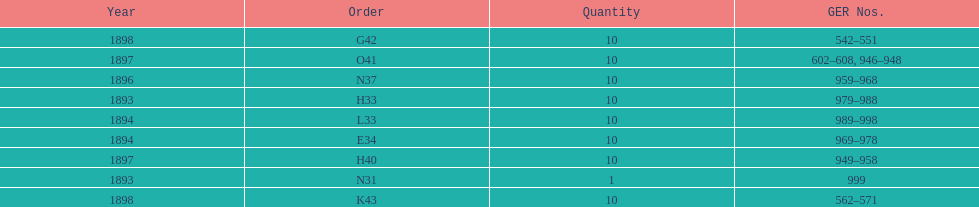What is the order of the last year listed? K43. 